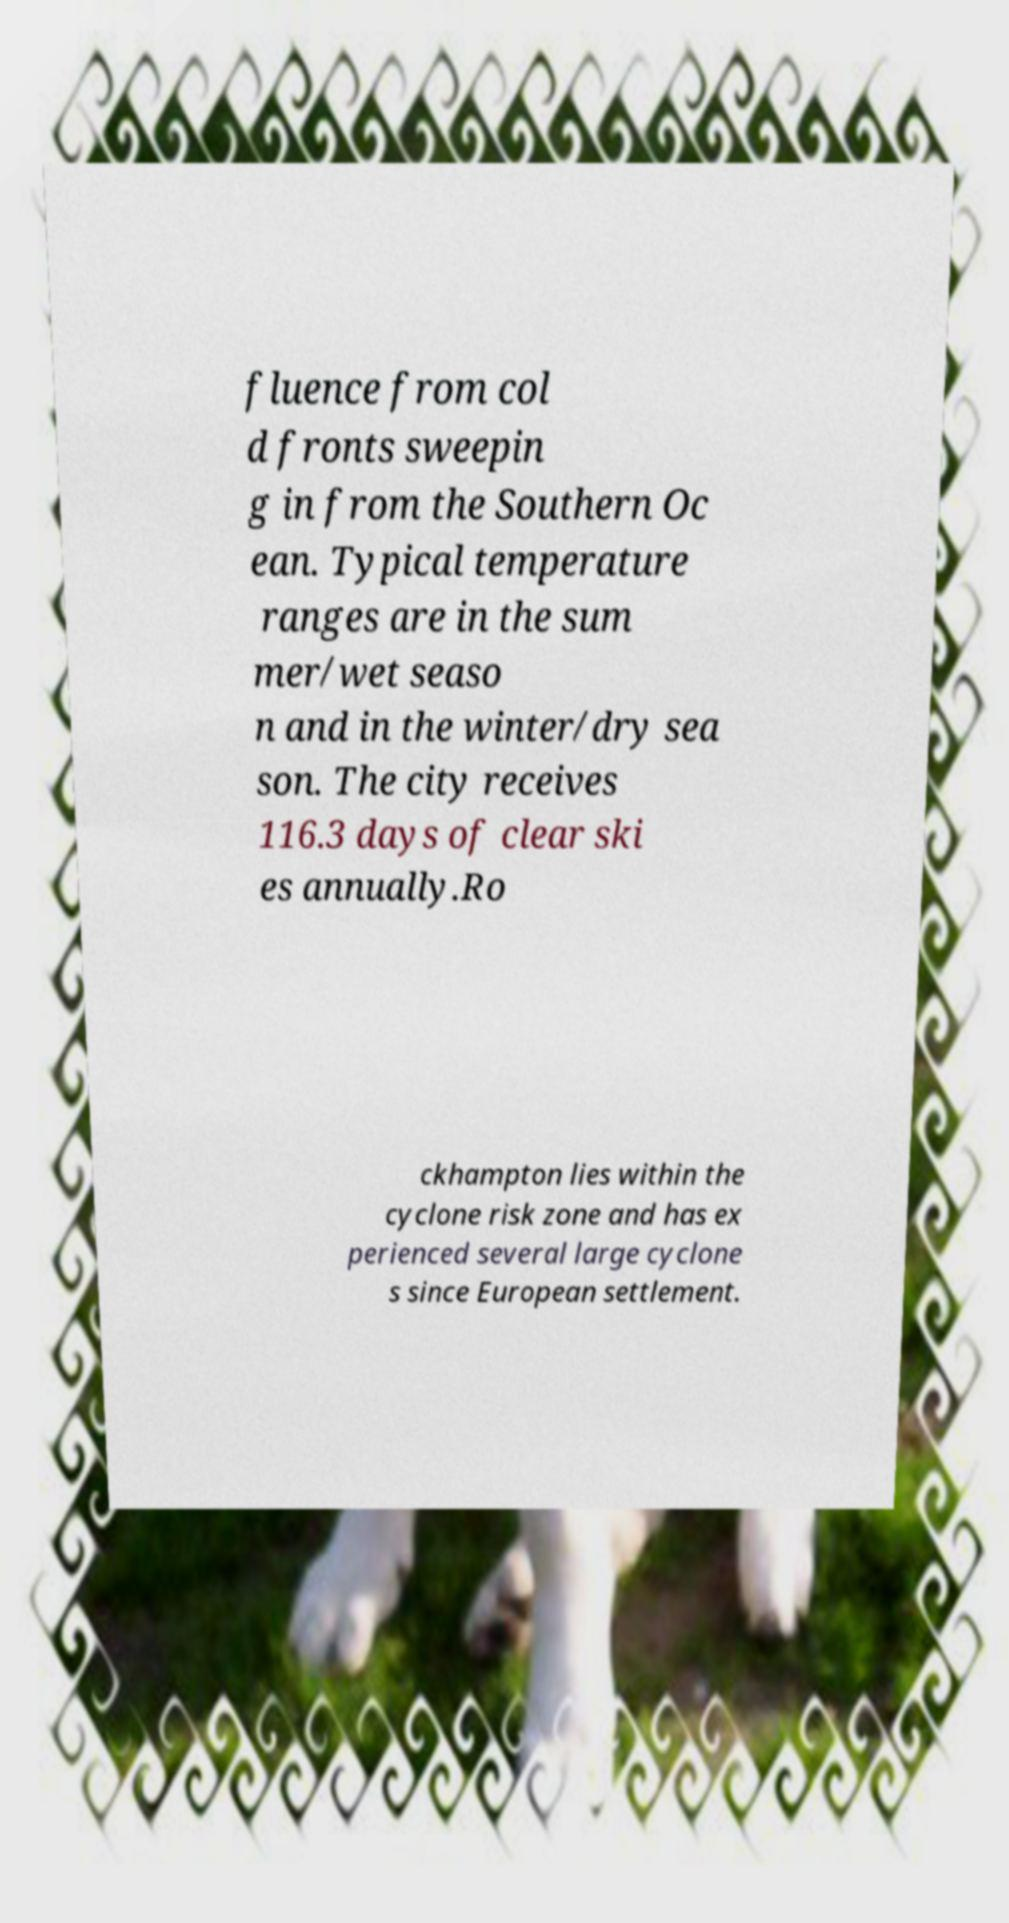Can you read and provide the text displayed in the image?This photo seems to have some interesting text. Can you extract and type it out for me? fluence from col d fronts sweepin g in from the Southern Oc ean. Typical temperature ranges are in the sum mer/wet seaso n and in the winter/dry sea son. The city receives 116.3 days of clear ski es annually.Ro ckhampton lies within the cyclone risk zone and has ex perienced several large cyclone s since European settlement. 